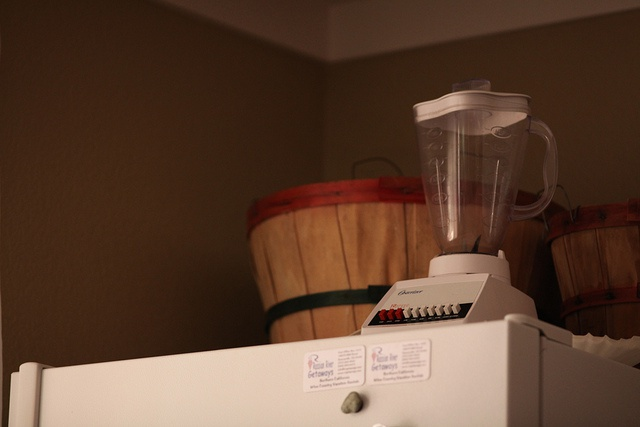Describe the objects in this image and their specific colors. I can see a refrigerator in black, tan, and maroon tones in this image. 